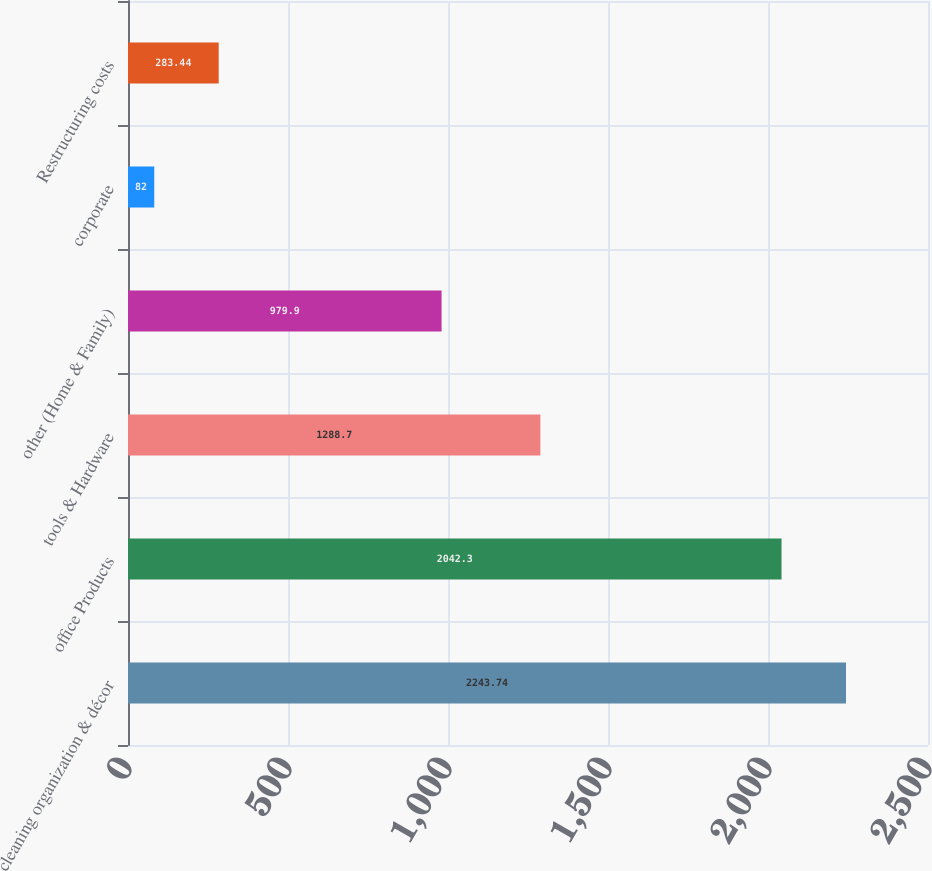Convert chart. <chart><loc_0><loc_0><loc_500><loc_500><bar_chart><fcel>cleaning organization & décor<fcel>office Products<fcel>tools & Hardware<fcel>other (Home & Family)<fcel>corporate<fcel>Restructuring costs<nl><fcel>2243.74<fcel>2042.3<fcel>1288.7<fcel>979.9<fcel>82<fcel>283.44<nl></chart> 